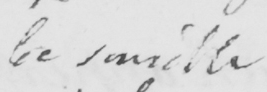Please transcribe the handwritten text in this image. be sensible 